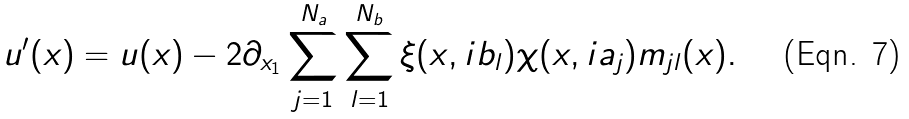Convert formula to latex. <formula><loc_0><loc_0><loc_500><loc_500>u ^ { \prime } ( x ) = u ( x ) - 2 \partial _ { x _ { 1 } } \sum _ { j = 1 } ^ { N _ { a } } \sum _ { l = 1 } ^ { N _ { b } } \xi ( x , i b _ { l } ) \chi ( x , i a _ { j } ) m _ { j l } ( x ) .</formula> 